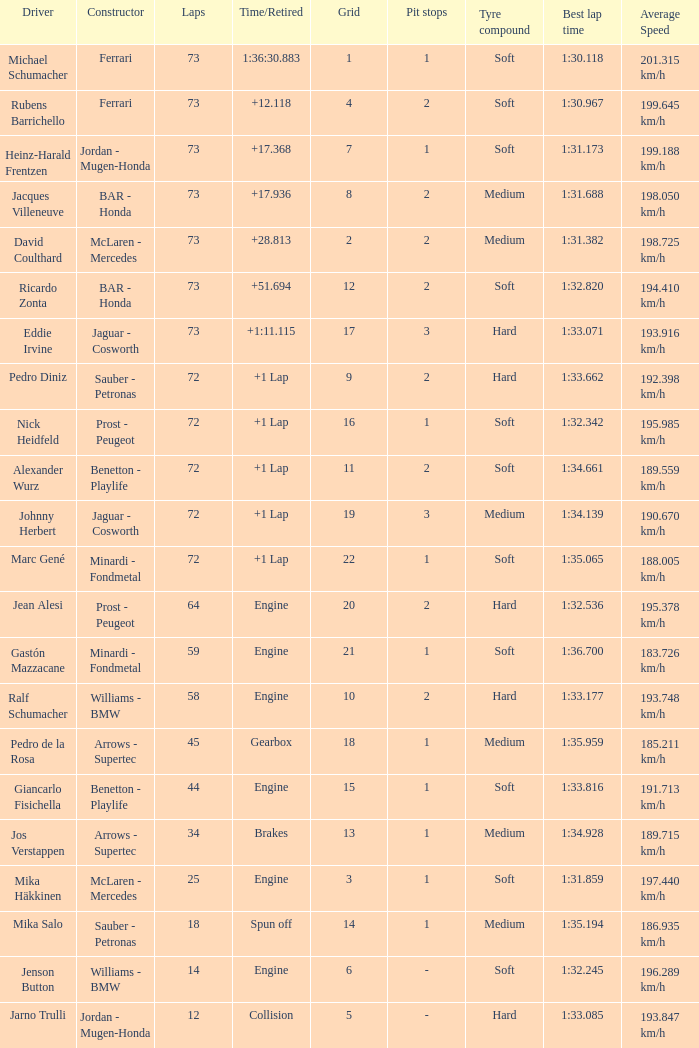How many laps did Jos Verstappen do on Grid 2? 34.0. 